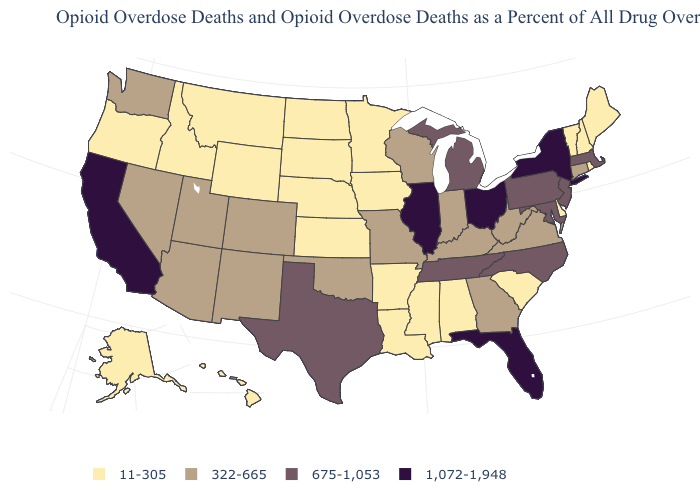Among the states that border Wisconsin , does Illinois have the highest value?
Quick response, please. Yes. Name the states that have a value in the range 322-665?
Answer briefly. Arizona, Colorado, Connecticut, Georgia, Indiana, Kentucky, Missouri, Nevada, New Mexico, Oklahoma, Utah, Virginia, Washington, West Virginia, Wisconsin. Name the states that have a value in the range 11-305?
Keep it brief. Alabama, Alaska, Arkansas, Delaware, Hawaii, Idaho, Iowa, Kansas, Louisiana, Maine, Minnesota, Mississippi, Montana, Nebraska, New Hampshire, North Dakota, Oregon, Rhode Island, South Carolina, South Dakota, Vermont, Wyoming. Does California have the highest value in the West?
Short answer required. Yes. What is the lowest value in states that border Rhode Island?
Short answer required. 322-665. Does Michigan have the lowest value in the MidWest?
Answer briefly. No. Which states hav the highest value in the Northeast?
Write a very short answer. New York. Does New York have the highest value in the Northeast?
Concise answer only. Yes. What is the value of Florida?
Quick response, please. 1,072-1,948. Does Delaware have the lowest value in the USA?
Answer briefly. Yes. What is the value of Florida?
Write a very short answer. 1,072-1,948. Which states have the lowest value in the USA?
Write a very short answer. Alabama, Alaska, Arkansas, Delaware, Hawaii, Idaho, Iowa, Kansas, Louisiana, Maine, Minnesota, Mississippi, Montana, Nebraska, New Hampshire, North Dakota, Oregon, Rhode Island, South Carolina, South Dakota, Vermont, Wyoming. Does Kentucky have the highest value in the USA?
Short answer required. No. Which states have the highest value in the USA?
Give a very brief answer. California, Florida, Illinois, New York, Ohio. What is the lowest value in states that border Louisiana?
Concise answer only. 11-305. 